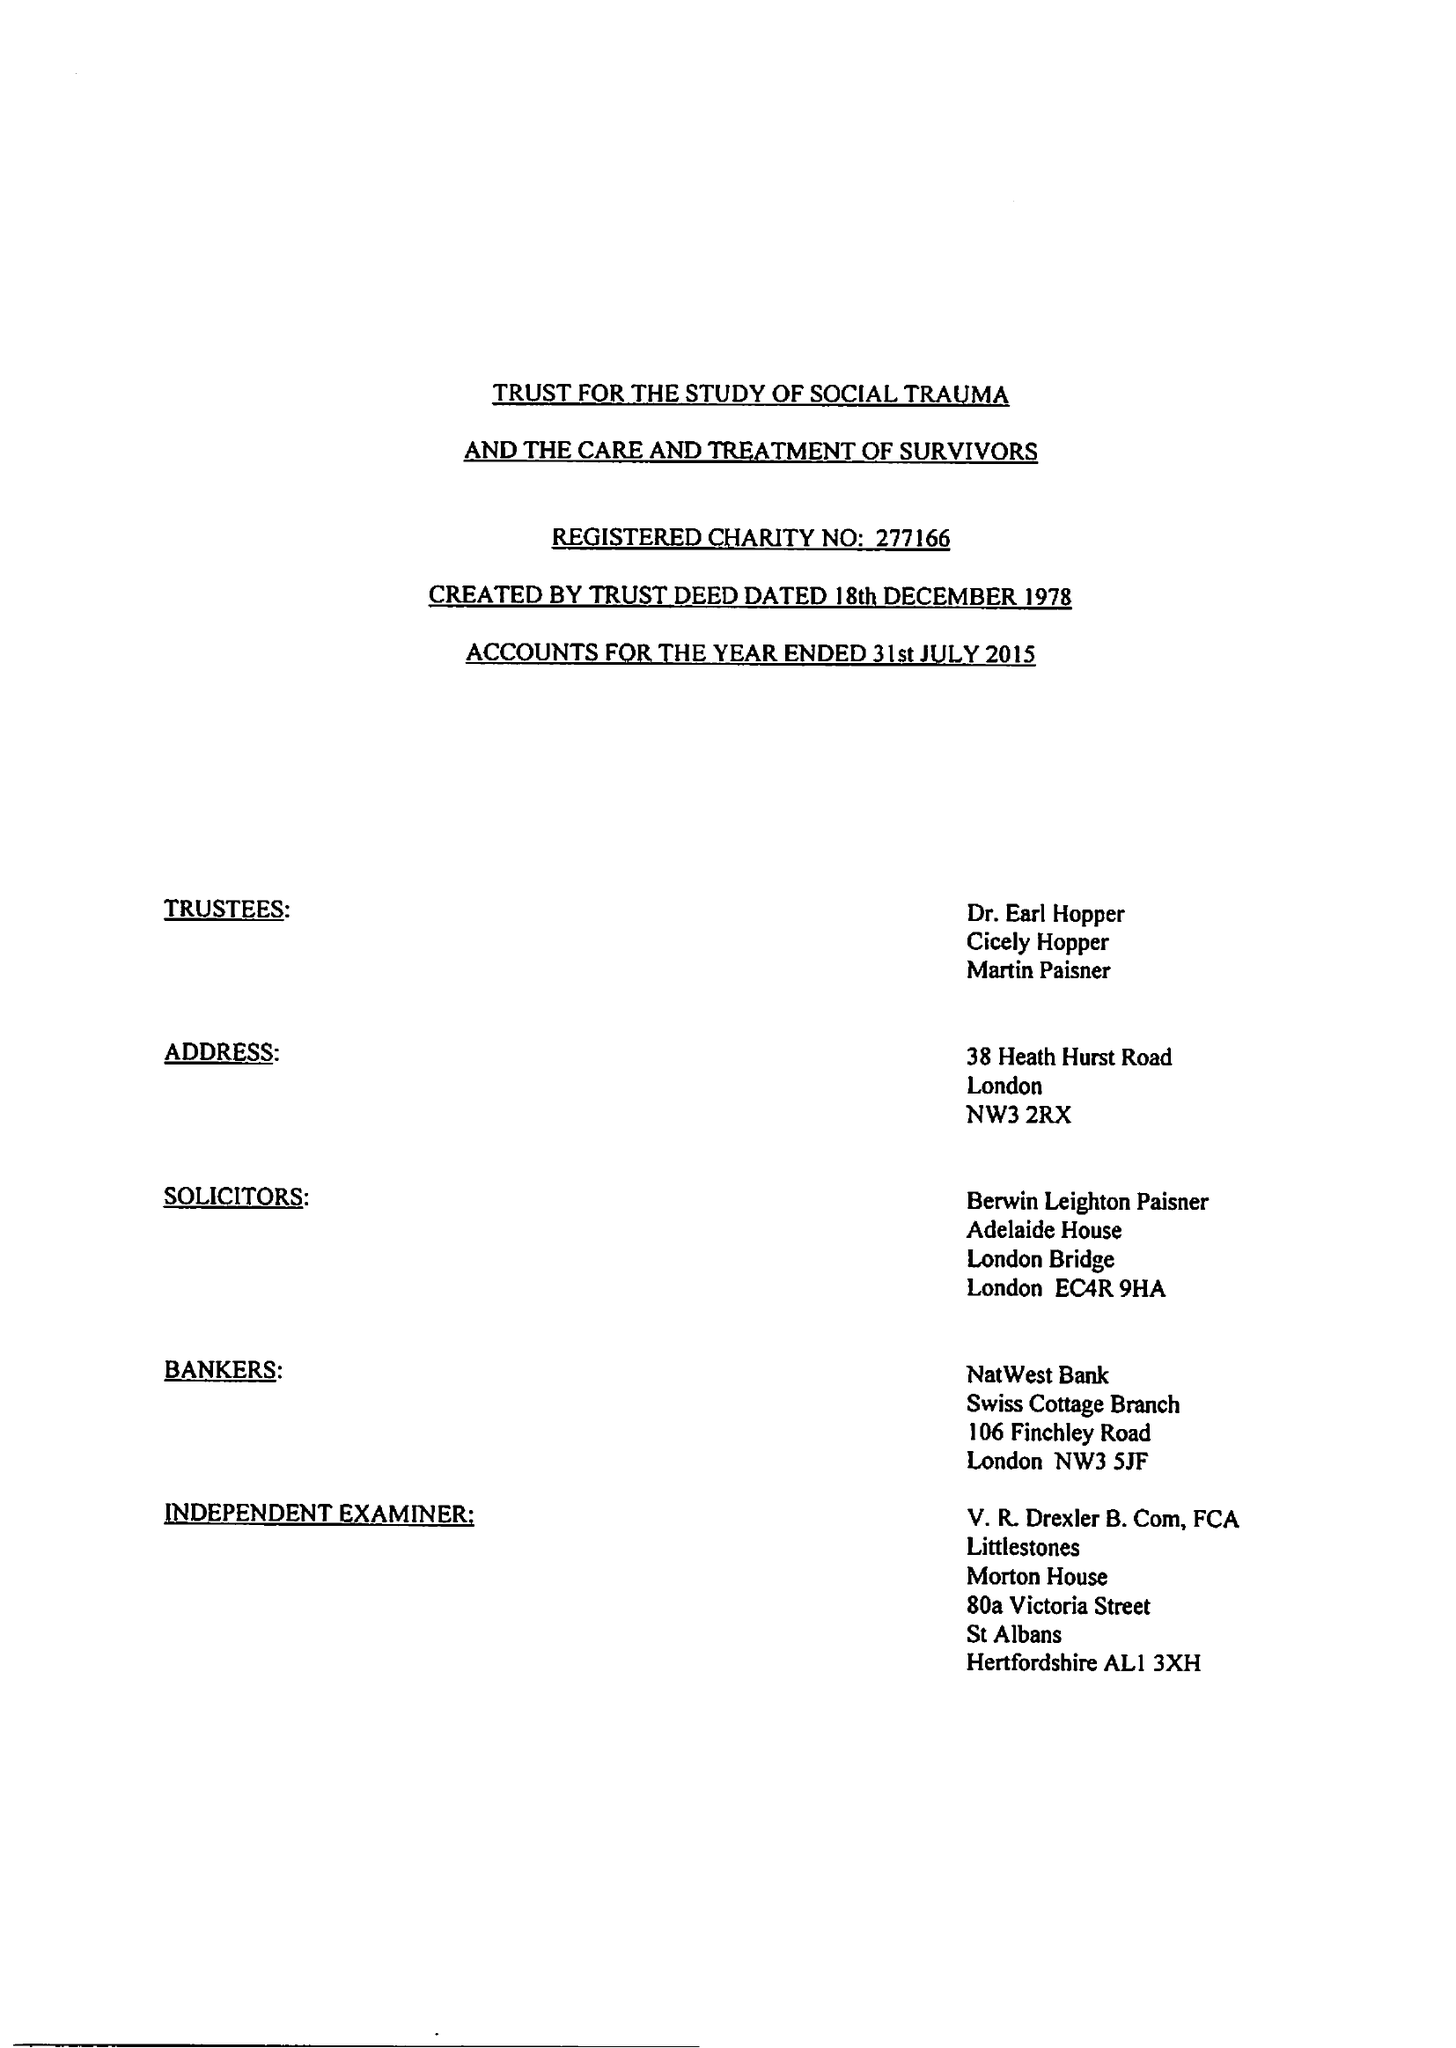What is the value for the address__postcode?
Answer the question using a single word or phrase. AL1 3XH 